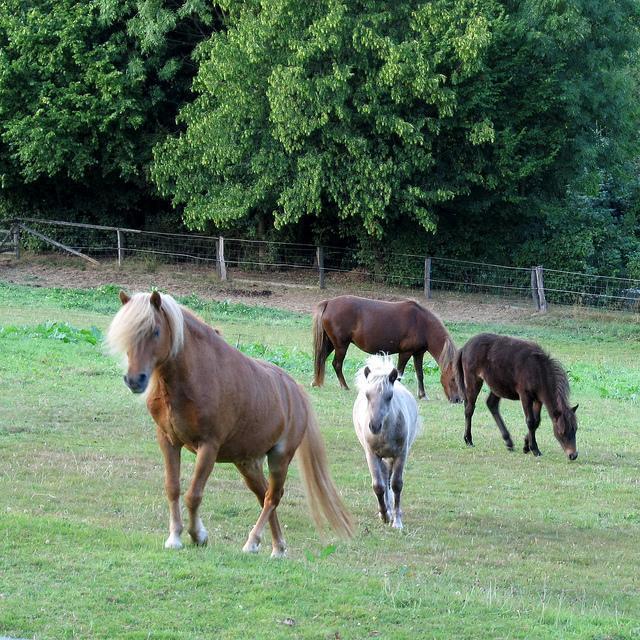How many horses are eating?
Give a very brief answer. 2. How many horses are there?
Give a very brief answer. 4. How many horses are in the picture?
Give a very brief answer. 4. 